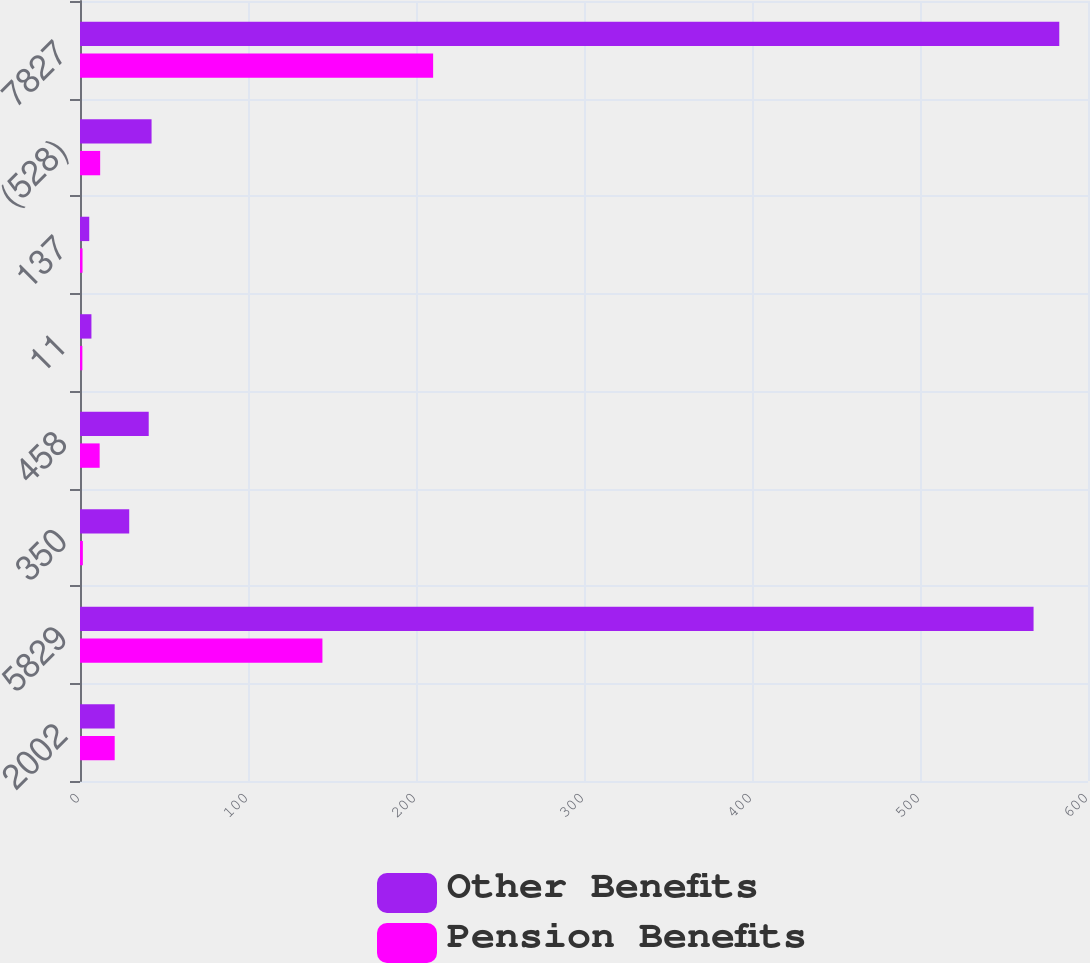Convert chart. <chart><loc_0><loc_0><loc_500><loc_500><stacked_bar_chart><ecel><fcel>2002<fcel>5829<fcel>350<fcel>458<fcel>11<fcel>137<fcel>(528)<fcel>7827<nl><fcel>Other Benefits<fcel>20.65<fcel>567.6<fcel>29.3<fcel>40.9<fcel>6.8<fcel>5.5<fcel>42.6<fcel>582.9<nl><fcel>Pension Benefits<fcel>20.65<fcel>144.3<fcel>1.7<fcel>11.7<fcel>1.4<fcel>1.5<fcel>12<fcel>210.2<nl></chart> 